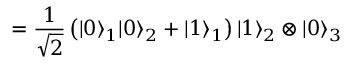<formula> <loc_0><loc_0><loc_500><loc_500>= \frac { 1 } { \sqrt { 2 } } \left ( | 0 \rangle _ { 1 } | 0 \rangle _ { 2 } + | 1 \rangle _ { 1 } \right ) | 1 \rangle _ { 2 } \otimes | 0 \rangle _ { 3 }</formula> 